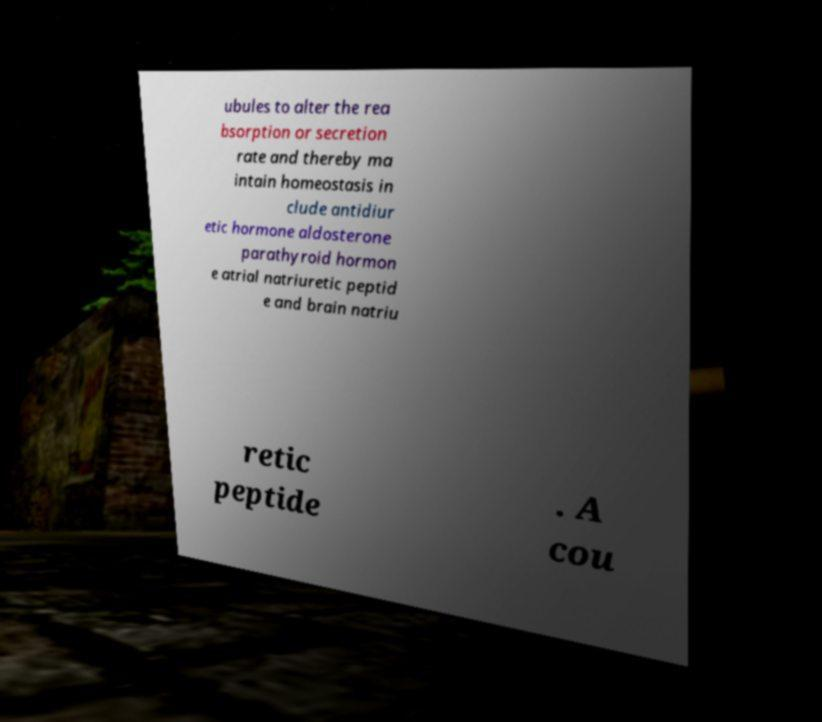Please identify and transcribe the text found in this image. ubules to alter the rea bsorption or secretion rate and thereby ma intain homeostasis in clude antidiur etic hormone aldosterone parathyroid hormon e atrial natriuretic peptid e and brain natriu retic peptide . A cou 